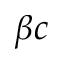<formula> <loc_0><loc_0><loc_500><loc_500>\beta { c }</formula> 